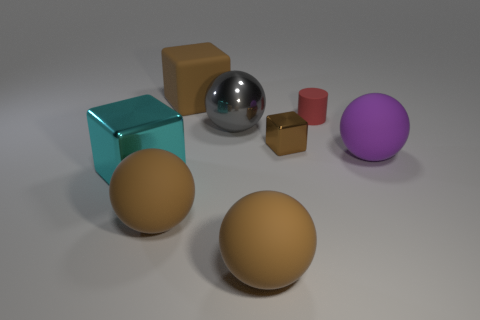There is a red cylinder; does it have the same size as the brown matte thing behind the large cyan metal cube?
Your answer should be very brief. No. There is a tiny metal thing that is the same shape as the large cyan object; what is its color?
Offer a terse response. Brown. The rubber cube is what color?
Ensure brevity in your answer.  Brown. Do the purple rubber sphere and the gray shiny sphere have the same size?
Provide a short and direct response. Yes. Is there any other thing that is the same shape as the tiny brown object?
Keep it short and to the point. Yes. Is the material of the red cylinder the same as the large brown object behind the cyan thing?
Your answer should be very brief. Yes. There is a big block that is in front of the cylinder; is its color the same as the big matte cube?
Your response must be concise. No. How many brown things are right of the large brown rubber block and behind the big purple sphere?
Offer a terse response. 1. What number of other things are made of the same material as the tiny brown cube?
Your answer should be very brief. 2. Do the brown cube behind the shiny ball and the gray object have the same material?
Your answer should be very brief. No. 